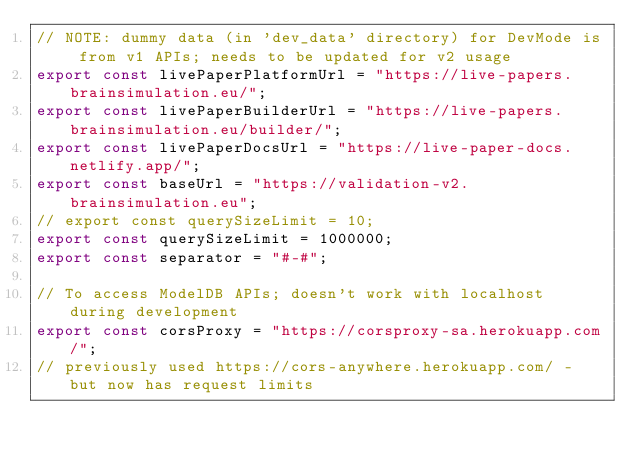Convert code to text. <code><loc_0><loc_0><loc_500><loc_500><_JavaScript_>// NOTE: dummy data (in 'dev_data' directory) for DevMode is from v1 APIs; needs to be updated for v2 usage
export const livePaperPlatformUrl = "https://live-papers.brainsimulation.eu/";
export const livePaperBuilderUrl = "https://live-papers.brainsimulation.eu/builder/";
export const livePaperDocsUrl = "https://live-paper-docs.netlify.app/";
export const baseUrl = "https://validation-v2.brainsimulation.eu";
// export const querySizeLimit = 10;
export const querySizeLimit = 1000000;
export const separator = "#-#";

// To access ModelDB APIs; doesn't work with localhost during development
export const corsProxy = "https://corsproxy-sa.herokuapp.com/";
// previously used https://cors-anywhere.herokuapp.com/ - but now has request limits</code> 